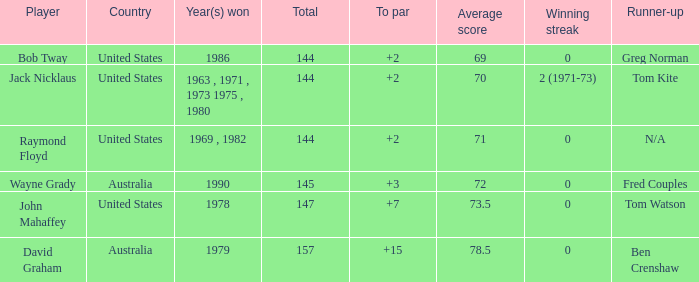How many strokes off par was the winner in 1978? 7.0. 